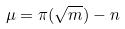<formula> <loc_0><loc_0><loc_500><loc_500>\mu = \pi ( \sqrt { m } ) - n</formula> 